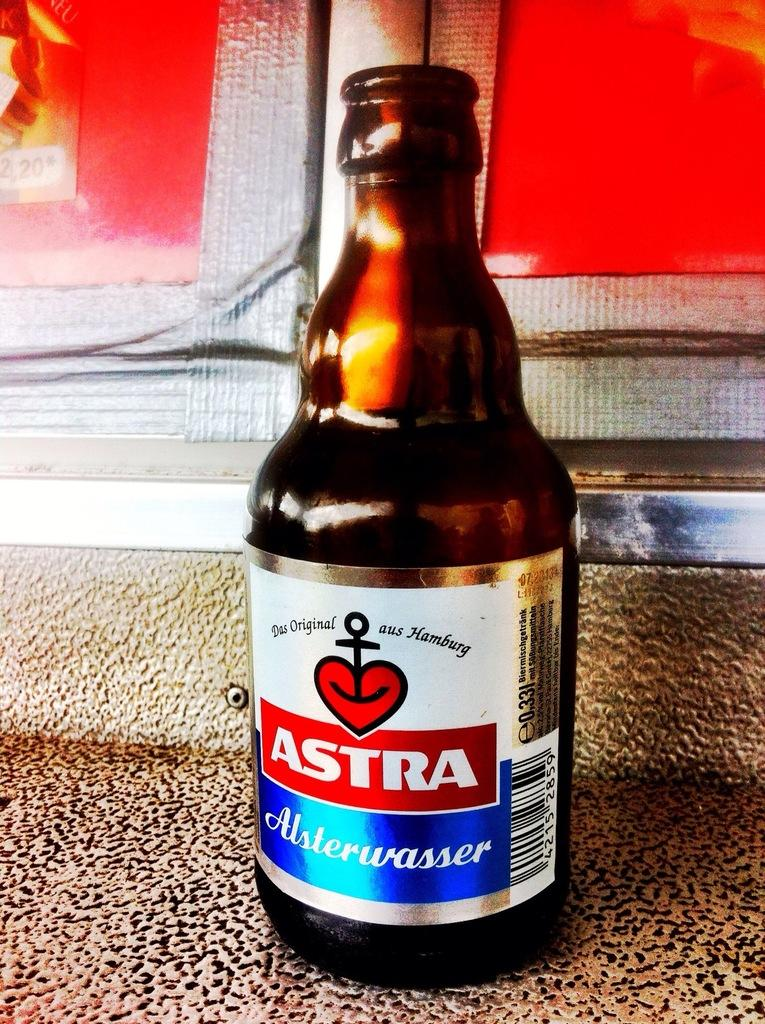<image>
Present a compact description of the photo's key features. A brown beer bottle labeled as Astra Alsterwaser. 